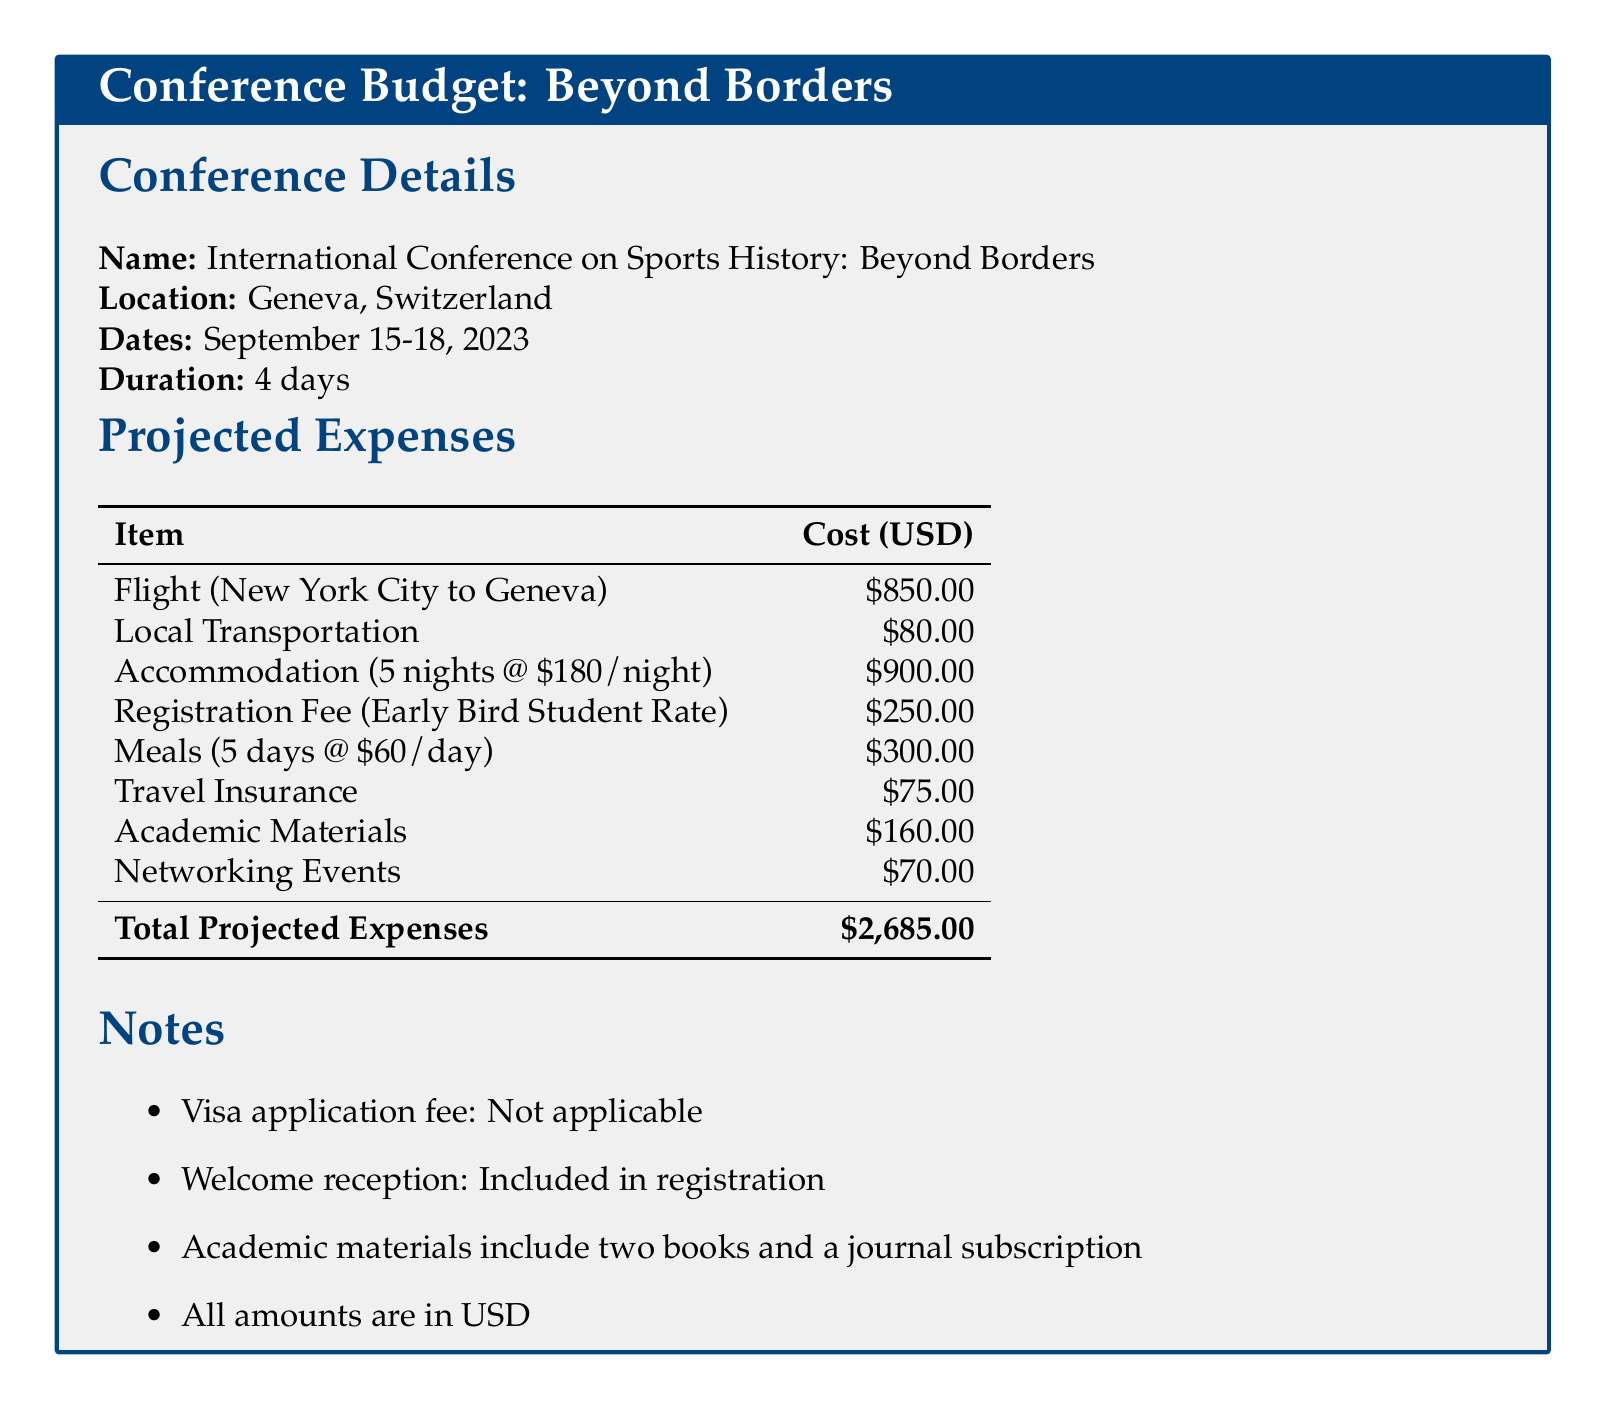What is the location of the conference? The location of the conference is explicitly mentioned in the document.
Answer: Geneva, Switzerland What are the dates of the conference? The document provides specific dates for the event in the conference details section.
Answer: September 15-18, 2023 What is the cost of accommodation? The document specifies the total accommodation cost derived from the nightly rate and the number of nights.
Answer: $900.00 What is the total projected expense for attending the conference? The total projected expenses are summarized at the end of the expenses table.
Answer: $2,685.00 How much does local transportation cost? The cost for local transportation is listed clearly in the table under projected expenses.
Answer: $80.00 What is included in the academic materials expense? The document notes that academic materials consist of two books and a journal subscription.
Answer: Two books and a journal subscription How many nights will the accommodation cover? The accommodation cost is calculated based on the number of nights stated in the budget section.
Answer: 5 nights Is the visa application fee applicable for this conference? The notes section explicitly states whether the visa application fee is relevant for attendees.
Answer: Not applicable What is the early bird registration fee for students? The registration fee is specified, and the document indicates this is the cost for students attending early.
Answer: $250.00 